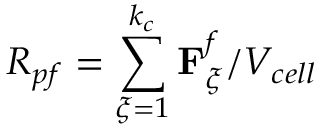Convert formula to latex. <formula><loc_0><loc_0><loc_500><loc_500>R _ { p f } = \sum _ { \xi = 1 } ^ { k _ { c } } F _ { \xi } ^ { f } / V _ { c e l l }</formula> 